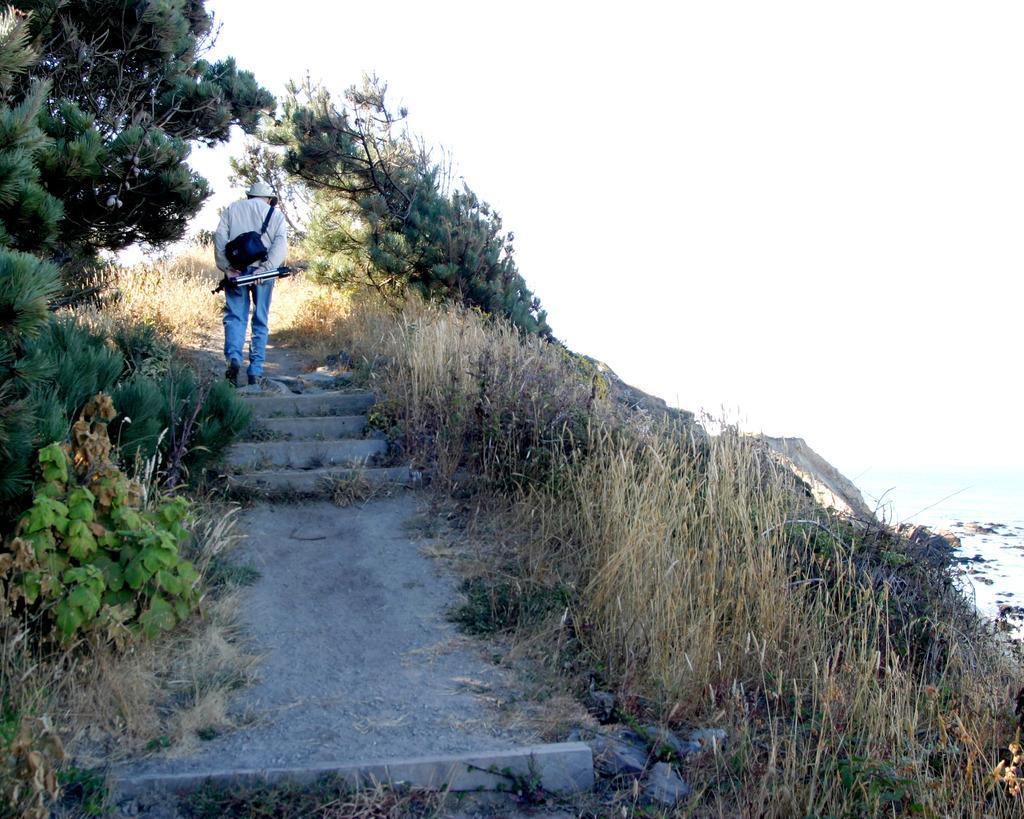Please provide a concise description of this image. In the middle a man is walking and these are the trees. 